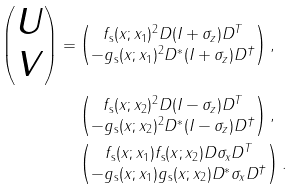Convert formula to latex. <formula><loc_0><loc_0><loc_500><loc_500>\begin{pmatrix} U \\ V \end{pmatrix} = & \begin{pmatrix} f _ { \text {s} } ( x ; x _ { 1 } ) ^ { 2 } D ( I + \sigma _ { z } ) D ^ { T } \\ - g _ { \text {s} } ( x ; x _ { 1 } ) ^ { 2 } D ^ { * } ( I + \sigma _ { z } ) D ^ { \dagger } \end{pmatrix} , \\ & \begin{pmatrix} f _ { \text {s} } ( x ; x _ { 2 } ) ^ { 2 } D ( I - \sigma _ { z } ) D ^ { T } \\ - g _ { \text {s} } ( x ; x _ { 2 } ) ^ { 2 } D ^ { * } ( I - \sigma _ { z } ) D ^ { \dagger } \end{pmatrix} , \\ & \begin{pmatrix} f _ { \text {s} } ( x ; x _ { 1 } ) f _ { \text {s} } ( x ; x _ { 2 } ) D \sigma _ { x } D ^ { T } \\ - g _ { \text {s} } ( x ; x _ { 1 } ) g _ { \text {s} } ( x ; x _ { 2 } ) D ^ { * } \sigma _ { x } D ^ { \dagger } \end{pmatrix} .</formula> 